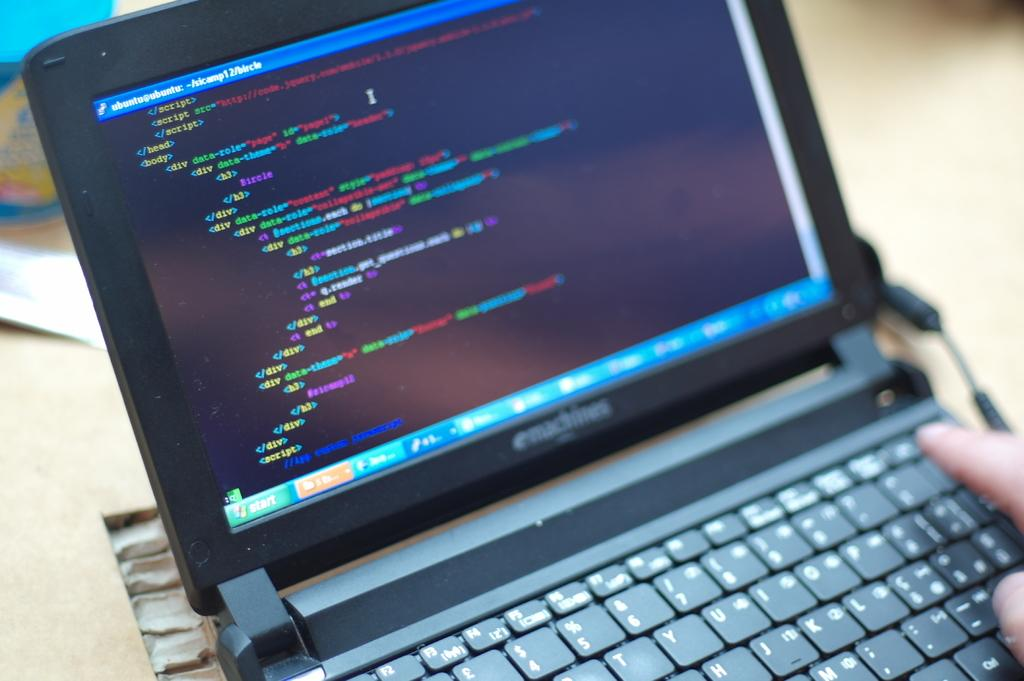<image>
Render a clear and concise summary of the photo. An emachines laptop running a script with the start button on the lower left. 